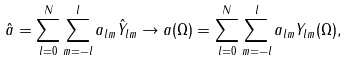<formula> <loc_0><loc_0><loc_500><loc_500>\hat { a } = \sum _ { l = 0 } ^ { N } \sum _ { m = - l } ^ { l } a _ { l m } \hat { Y } _ { l m } \rightarrow a ( \Omega ) = \sum _ { l = 0 } ^ { N } \sum _ { m = - l } ^ { l } a _ { l m } Y _ { l m } ( \Omega ) ,</formula> 